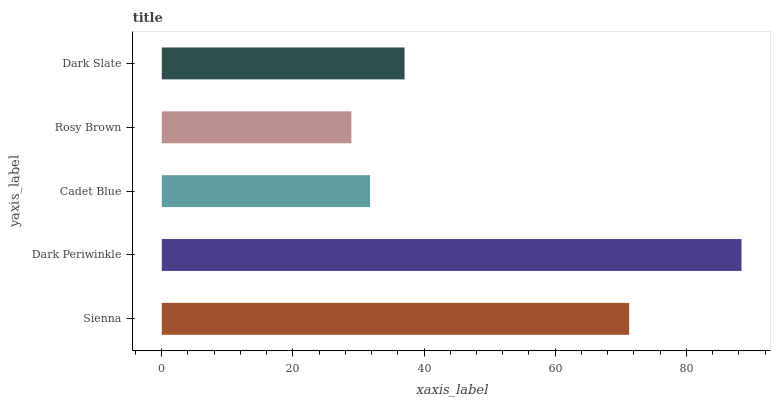Is Rosy Brown the minimum?
Answer yes or no. Yes. Is Dark Periwinkle the maximum?
Answer yes or no. Yes. Is Cadet Blue the minimum?
Answer yes or no. No. Is Cadet Blue the maximum?
Answer yes or no. No. Is Dark Periwinkle greater than Cadet Blue?
Answer yes or no. Yes. Is Cadet Blue less than Dark Periwinkle?
Answer yes or no. Yes. Is Cadet Blue greater than Dark Periwinkle?
Answer yes or no. No. Is Dark Periwinkle less than Cadet Blue?
Answer yes or no. No. Is Dark Slate the high median?
Answer yes or no. Yes. Is Dark Slate the low median?
Answer yes or no. Yes. Is Sienna the high median?
Answer yes or no. No. Is Dark Periwinkle the low median?
Answer yes or no. No. 